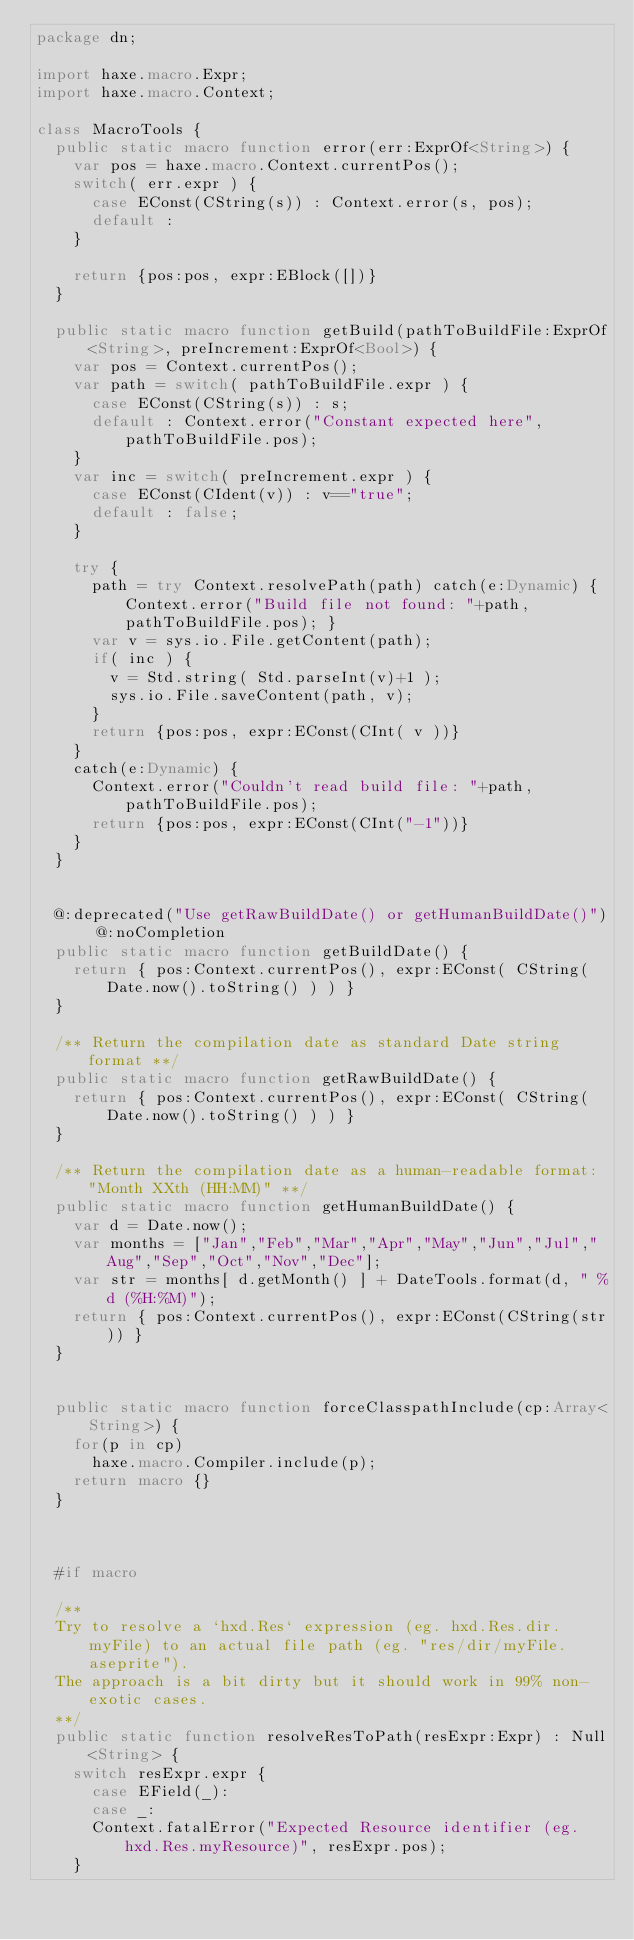<code> <loc_0><loc_0><loc_500><loc_500><_Haxe_>package dn;

import haxe.macro.Expr;
import haxe.macro.Context;

class MacroTools {
	public static macro function error(err:ExprOf<String>) {
		var pos = haxe.macro.Context.currentPos();
		switch( err.expr ) {
			case EConst(CString(s)) : Context.error(s, pos);
			default :
		}

		return {pos:pos, expr:EBlock([])}
	}

	public static macro function getBuild(pathToBuildFile:ExprOf<String>, preIncrement:ExprOf<Bool>) {
		var pos = Context.currentPos();
		var path = switch( pathToBuildFile.expr ) {
			case EConst(CString(s)) : s;
			default : Context.error("Constant expected here", pathToBuildFile.pos);
		}
		var inc = switch( preIncrement.expr ) {
			case EConst(CIdent(v)) : v=="true";
			default : false;
		}

		try {
			path = try Context.resolvePath(path) catch(e:Dynamic) { Context.error("Build file not found: "+path, pathToBuildFile.pos); }
			var v = sys.io.File.getContent(path);
			if( inc ) {
				v = Std.string( Std.parseInt(v)+1 );
				sys.io.File.saveContent(path, v);
			}
			return {pos:pos, expr:EConst(CInt( v ))}
		}
		catch(e:Dynamic) {
			Context.error("Couldn't read build file: "+path, pathToBuildFile.pos);
			return {pos:pos, expr:EConst(CInt("-1"))}
		}
	}


	@:deprecated("Use getRawBuildDate() or getHumanBuildDate()") @:noCompletion
	public static macro function getBuildDate() {
		return { pos:Context.currentPos(), expr:EConst( CString( Date.now().toString() ) ) }
	}

	/** Return the compilation date as standard Date string format **/
	public static macro function getRawBuildDate() {
		return { pos:Context.currentPos(), expr:EConst( CString( Date.now().toString() ) ) }
	}

	/** Return the compilation date as a human-readable format: "Month XXth (HH:MM)" **/
	public static macro function getHumanBuildDate() {
		var d = Date.now();
		var months = ["Jan","Feb","Mar","Apr","May","Jun","Jul","Aug","Sep","Oct","Nov","Dec"];
		var str = months[ d.getMonth() ] + DateTools.format(d, " %d (%H:%M)");
		return { pos:Context.currentPos(), expr:EConst(CString(str)) }
	}


	public static macro function forceClasspathInclude(cp:Array<String>) {
		for(p in cp)
			haxe.macro.Compiler.include(p);
		return macro {}
	}



	#if macro

	/**
	Try to resolve a `hxd.Res` expression (eg. hxd.Res.dir.myFile) to an actual file path (eg. "res/dir/myFile.aseprite").
	The approach is a bit dirty but it should work in 99% non-exotic cases.
	**/
	public static function resolveResToPath(resExpr:Expr) : Null<String> {
		switch resExpr.expr {
			case EField(_):
			case _:
			Context.fatalError("Expected Resource identifier (eg. hxd.Res.myResource)", resExpr.pos);
		}
</code> 